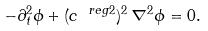Convert formula to latex. <formula><loc_0><loc_0><loc_500><loc_500>- \partial _ { t } ^ { 2 } \phi + ( c ^ { \ r e g { 2 } } ) ^ { 2 } \, \nabla ^ { 2 } \phi = 0 .</formula> 